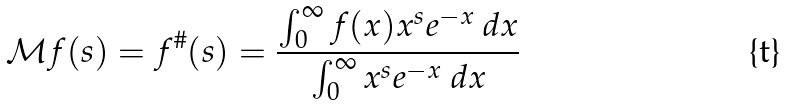<formula> <loc_0><loc_0><loc_500><loc_500>\mathcal { M } f ( s ) = f ^ { \# } ( s ) = \frac { \int _ { 0 } ^ { \infty } f ( x ) x ^ { s } e ^ { - x } \ d x } { \int _ { 0 } ^ { \infty } x ^ { s } e ^ { - x } \ d x }</formula> 